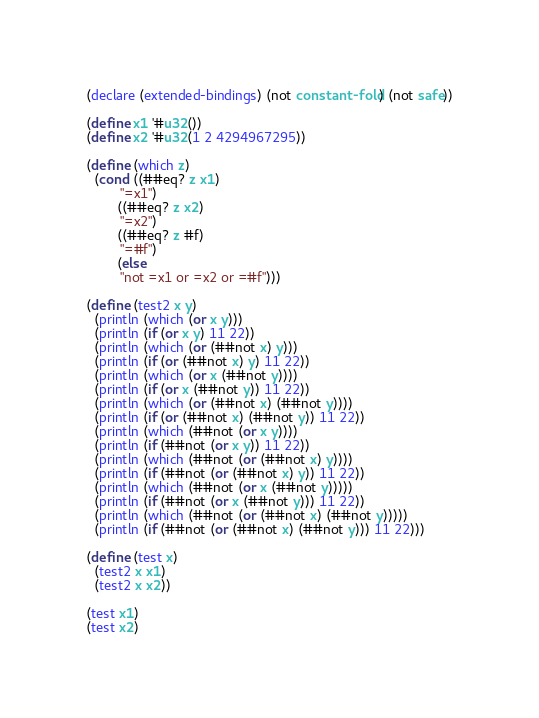<code> <loc_0><loc_0><loc_500><loc_500><_Scheme_>(declare (extended-bindings) (not constant-fold) (not safe))

(define x1 '#u32())
(define x2 '#u32(1 2 4294967295))

(define (which z)
  (cond ((##eq? z x1)
         "=x1")
        ((##eq? z x2)
         "=x2")
        ((##eq? z #f)
         "=#f")
        (else
         "not =x1 or =x2 or =#f")))

(define (test2 x y)
  (println (which (or x y)))
  (println (if (or x y) 11 22))
  (println (which (or (##not x) y)))
  (println (if (or (##not x) y) 11 22))
  (println (which (or x (##not y))))
  (println (if (or x (##not y)) 11 22))
  (println (which (or (##not x) (##not y))))
  (println (if (or (##not x) (##not y)) 11 22))
  (println (which (##not (or x y))))
  (println (if (##not (or x y)) 11 22))
  (println (which (##not (or (##not x) y))))
  (println (if (##not (or (##not x) y)) 11 22))
  (println (which (##not (or x (##not y)))))
  (println (if (##not (or x (##not y))) 11 22))
  (println (which (##not (or (##not x) (##not y)))))
  (println (if (##not (or (##not x) (##not y))) 11 22)))

(define (test x)
  (test2 x x1)
  (test2 x x2))

(test x1)
(test x2)
</code> 